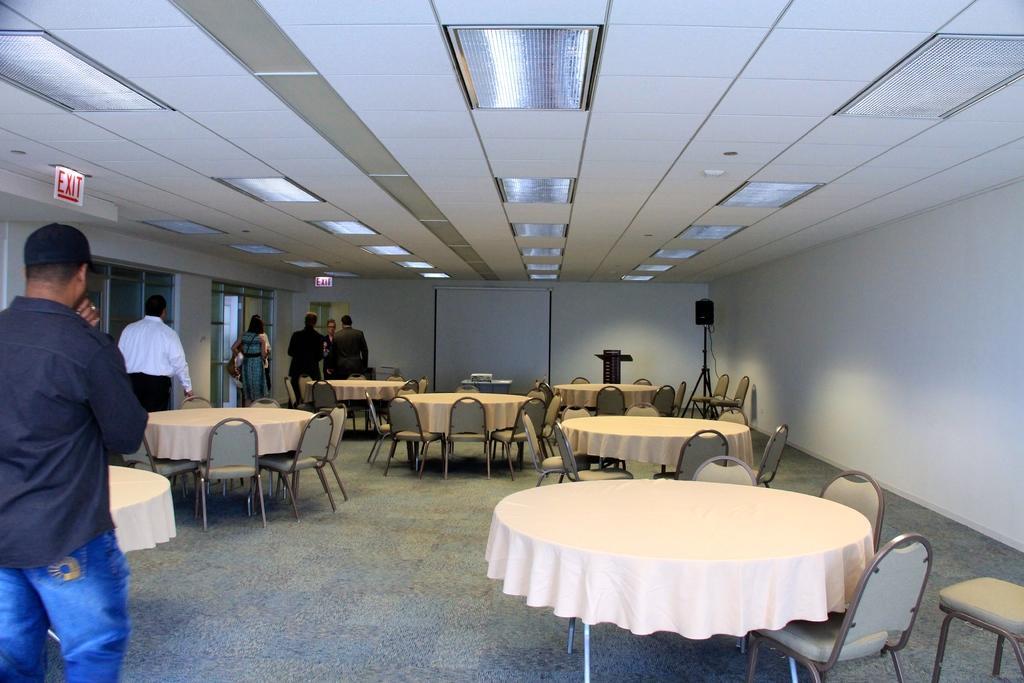In one or two sentences, can you explain what this image depicts? This picture shows few people standing and we see chairs and tables 